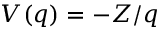Convert formula to latex. <formula><loc_0><loc_0><loc_500><loc_500>V ( q ) = - Z / q</formula> 